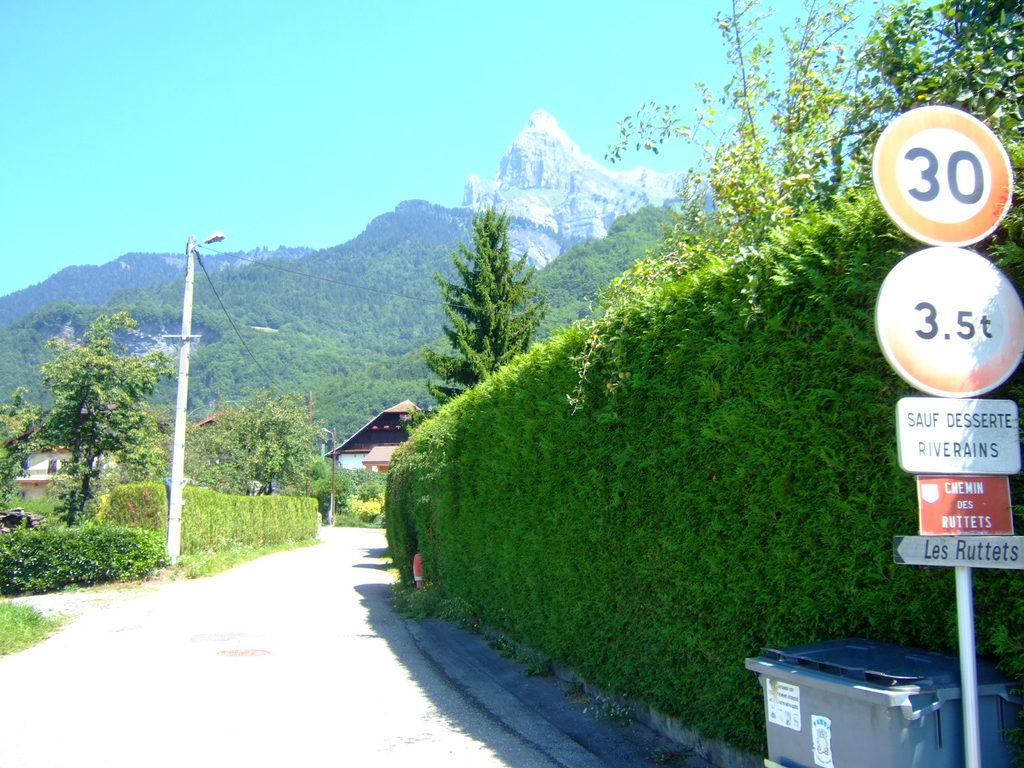<image>
Render a clear and concise summary of the photo. Signs are posted on a pole including one pointing to Les Ruttets. 